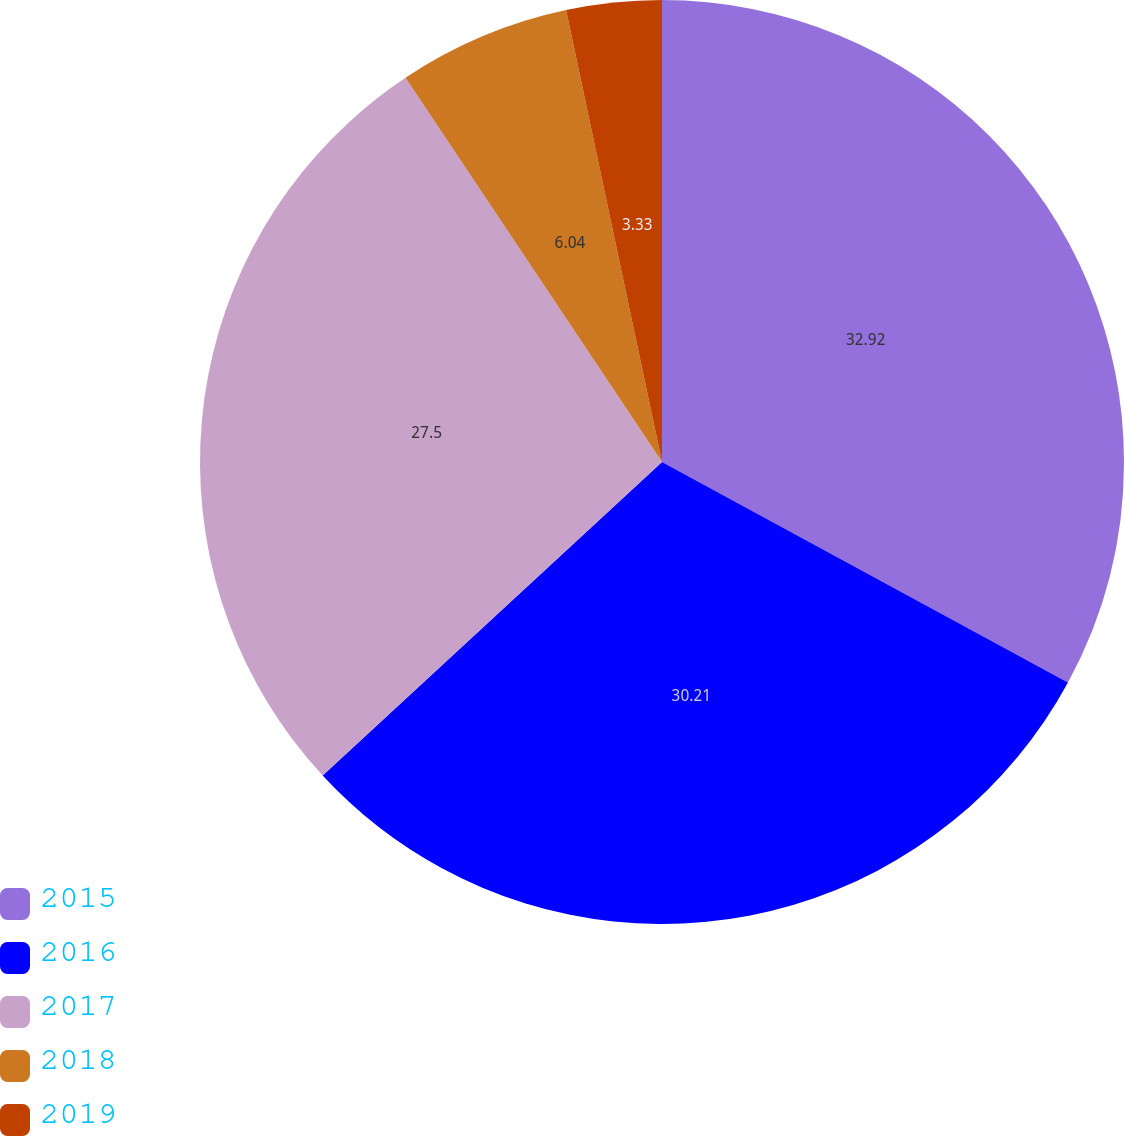Convert chart. <chart><loc_0><loc_0><loc_500><loc_500><pie_chart><fcel>2015<fcel>2016<fcel>2017<fcel>2018<fcel>2019<nl><fcel>32.92%<fcel>30.21%<fcel>27.5%<fcel>6.04%<fcel>3.33%<nl></chart> 